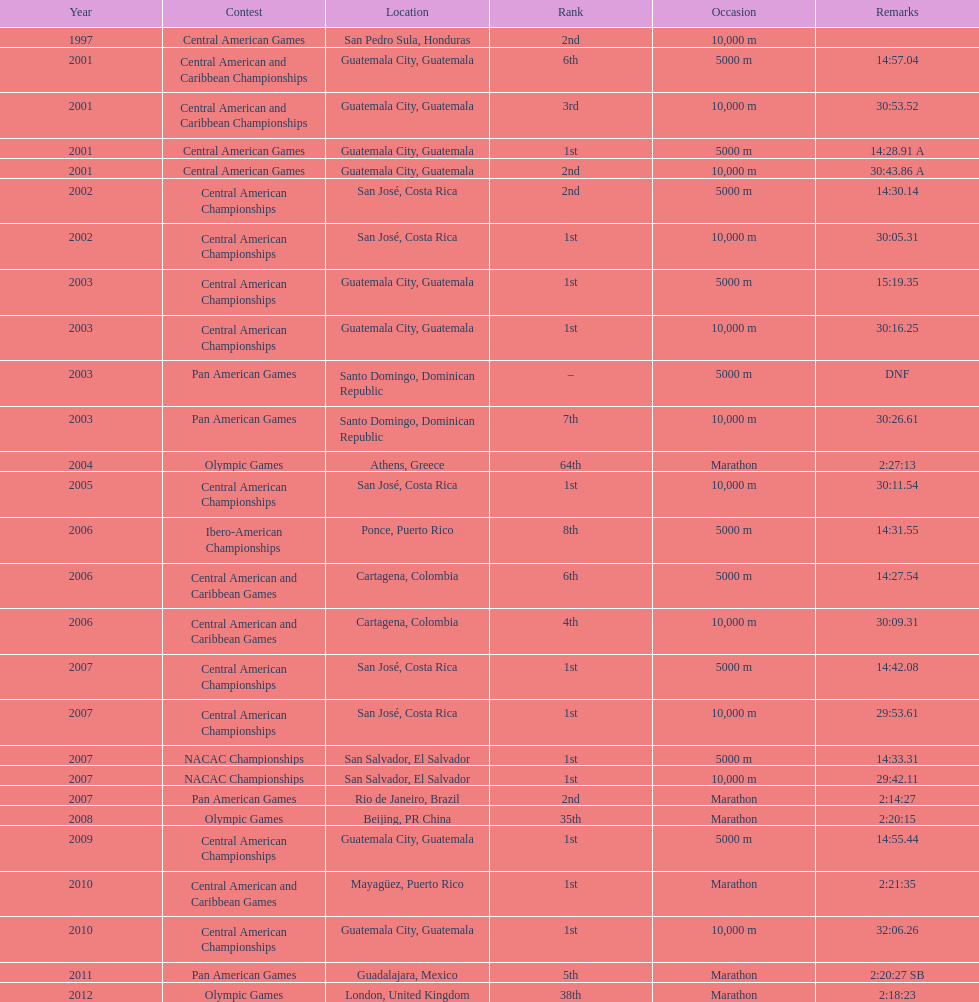Where was the only 64th position held? Athens, Greece. 